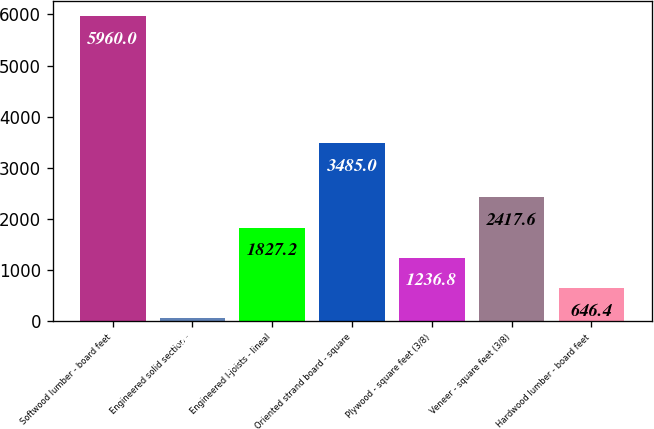<chart> <loc_0><loc_0><loc_500><loc_500><bar_chart><fcel>Softwood lumber - board feet<fcel>Engineered solid section -<fcel>Engineered I-joists - lineal<fcel>Oriented strand board - square<fcel>Plywood - square feet (3/8)<fcel>Veneer - square feet (3/8)<fcel>Hardwood lumber - board feet<nl><fcel>5960<fcel>56<fcel>1827.2<fcel>3485<fcel>1236.8<fcel>2417.6<fcel>646.4<nl></chart> 